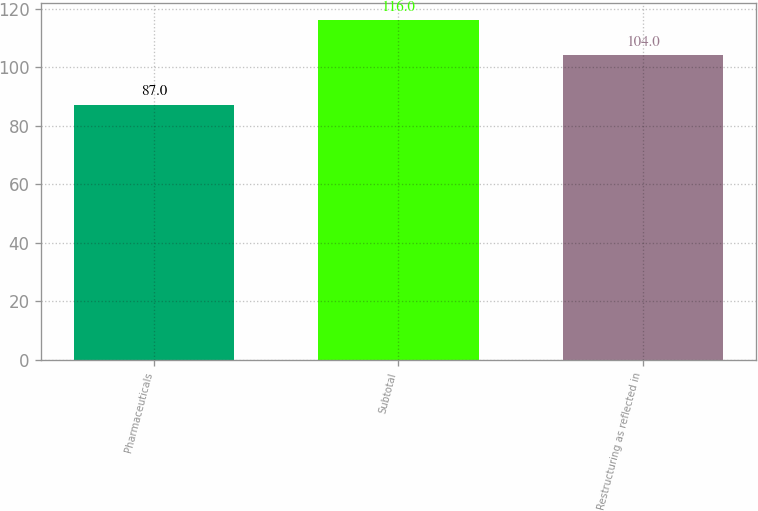Convert chart. <chart><loc_0><loc_0><loc_500><loc_500><bar_chart><fcel>Pharmaceuticals<fcel>Subtotal<fcel>Restructuring as reflected in<nl><fcel>87<fcel>116<fcel>104<nl></chart> 